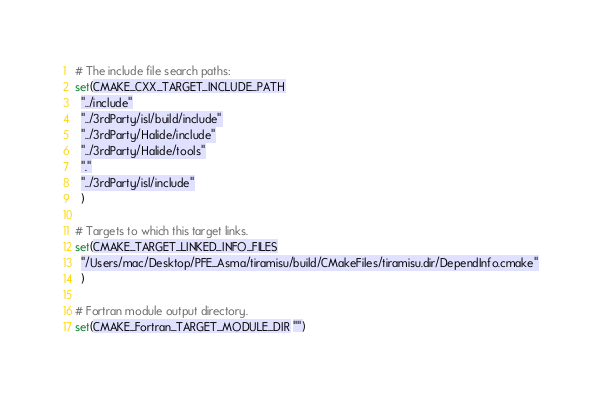<code> <loc_0><loc_0><loc_500><loc_500><_CMake_>
# The include file search paths:
set(CMAKE_CXX_TARGET_INCLUDE_PATH
  "../include"
  "../3rdParty/isl/build/include"
  "../3rdParty/Halide/include"
  "../3rdParty/Halide/tools"
  "."
  "../3rdParty/isl/include"
  )

# Targets to which this target links.
set(CMAKE_TARGET_LINKED_INFO_FILES
  "/Users/mac/Desktop/PFE_Asma/tiramisu/build/CMakeFiles/tiramisu.dir/DependInfo.cmake"
  )

# Fortran module output directory.
set(CMAKE_Fortran_TARGET_MODULE_DIR "")
</code> 